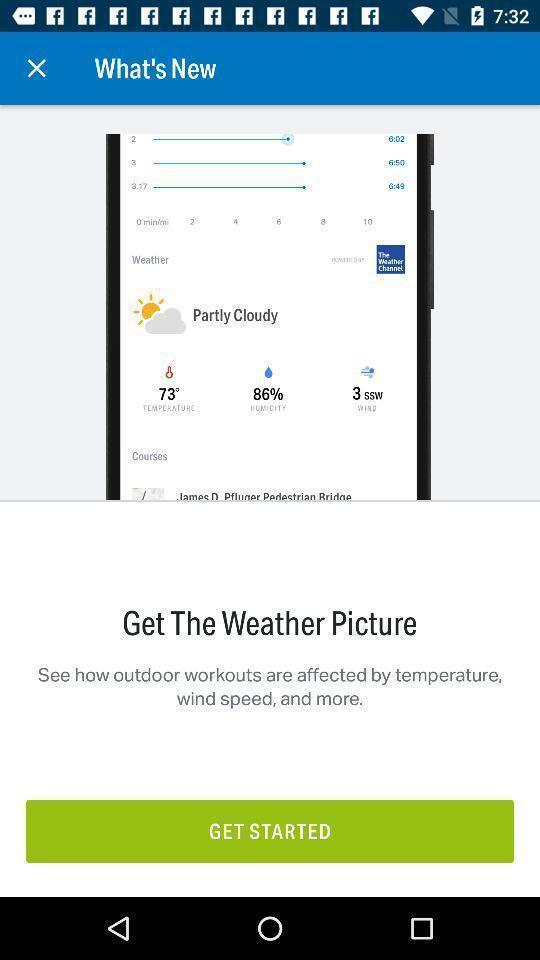Describe the content in this image. Welcome page of a weather app. 